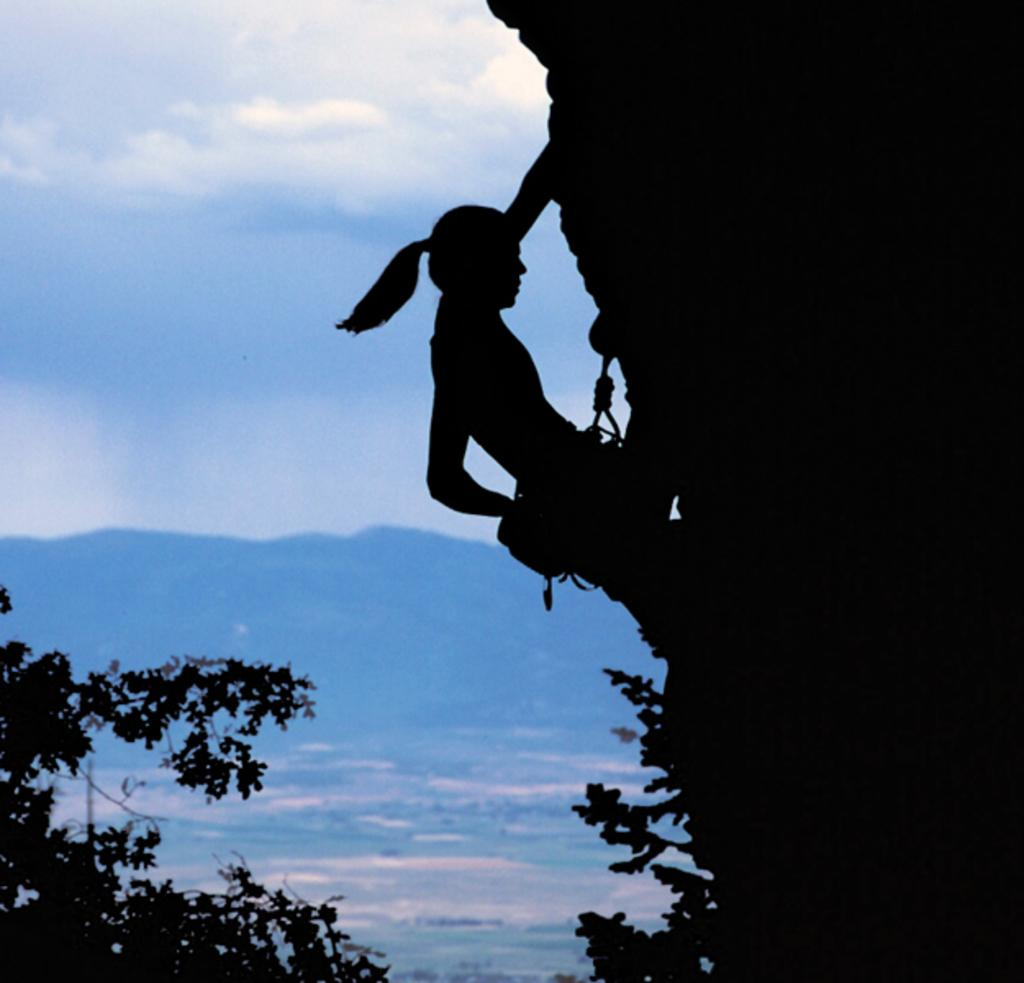Who is the main subject in the image? There is a woman in the image. What is the woman doing in the image? The woman is climbing a hill. In which direction is the woman moving? The woman is moving towards the right. What can be seen at the bottom of the hill? There are trees at the bottom of the hill. What is visible in the background of the image? There is another hill in the background and the sky is visible. What type of joke can be seen being told by the woman in the image? There is no joke being told in the image; the woman is climbing a hill. Can you tell me how many oceans are visible in the image? There are no oceans visible in the image; it features a woman climbing a hill with trees at the bottom and another hill in the background. 